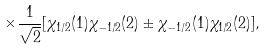Convert formula to latex. <formula><loc_0><loc_0><loc_500><loc_500>\times \frac { 1 } { \sqrt { 2 } } [ \chi _ { 1 / 2 } ( 1 ) \chi _ { - 1 / 2 } ( 2 ) \pm \chi _ { - 1 / 2 } ( 1 ) \chi _ { 1 / 2 } ( 2 ) ] ,</formula> 